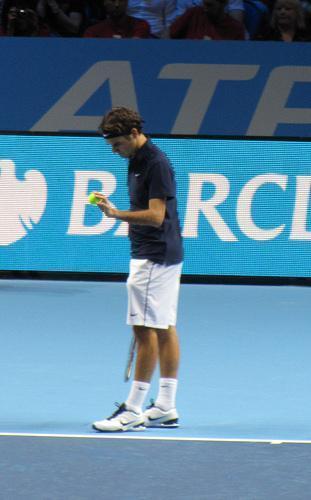How many people are visible?
Give a very brief answer. 1. How many basketballs is the man holding?
Give a very brief answer. 0. 